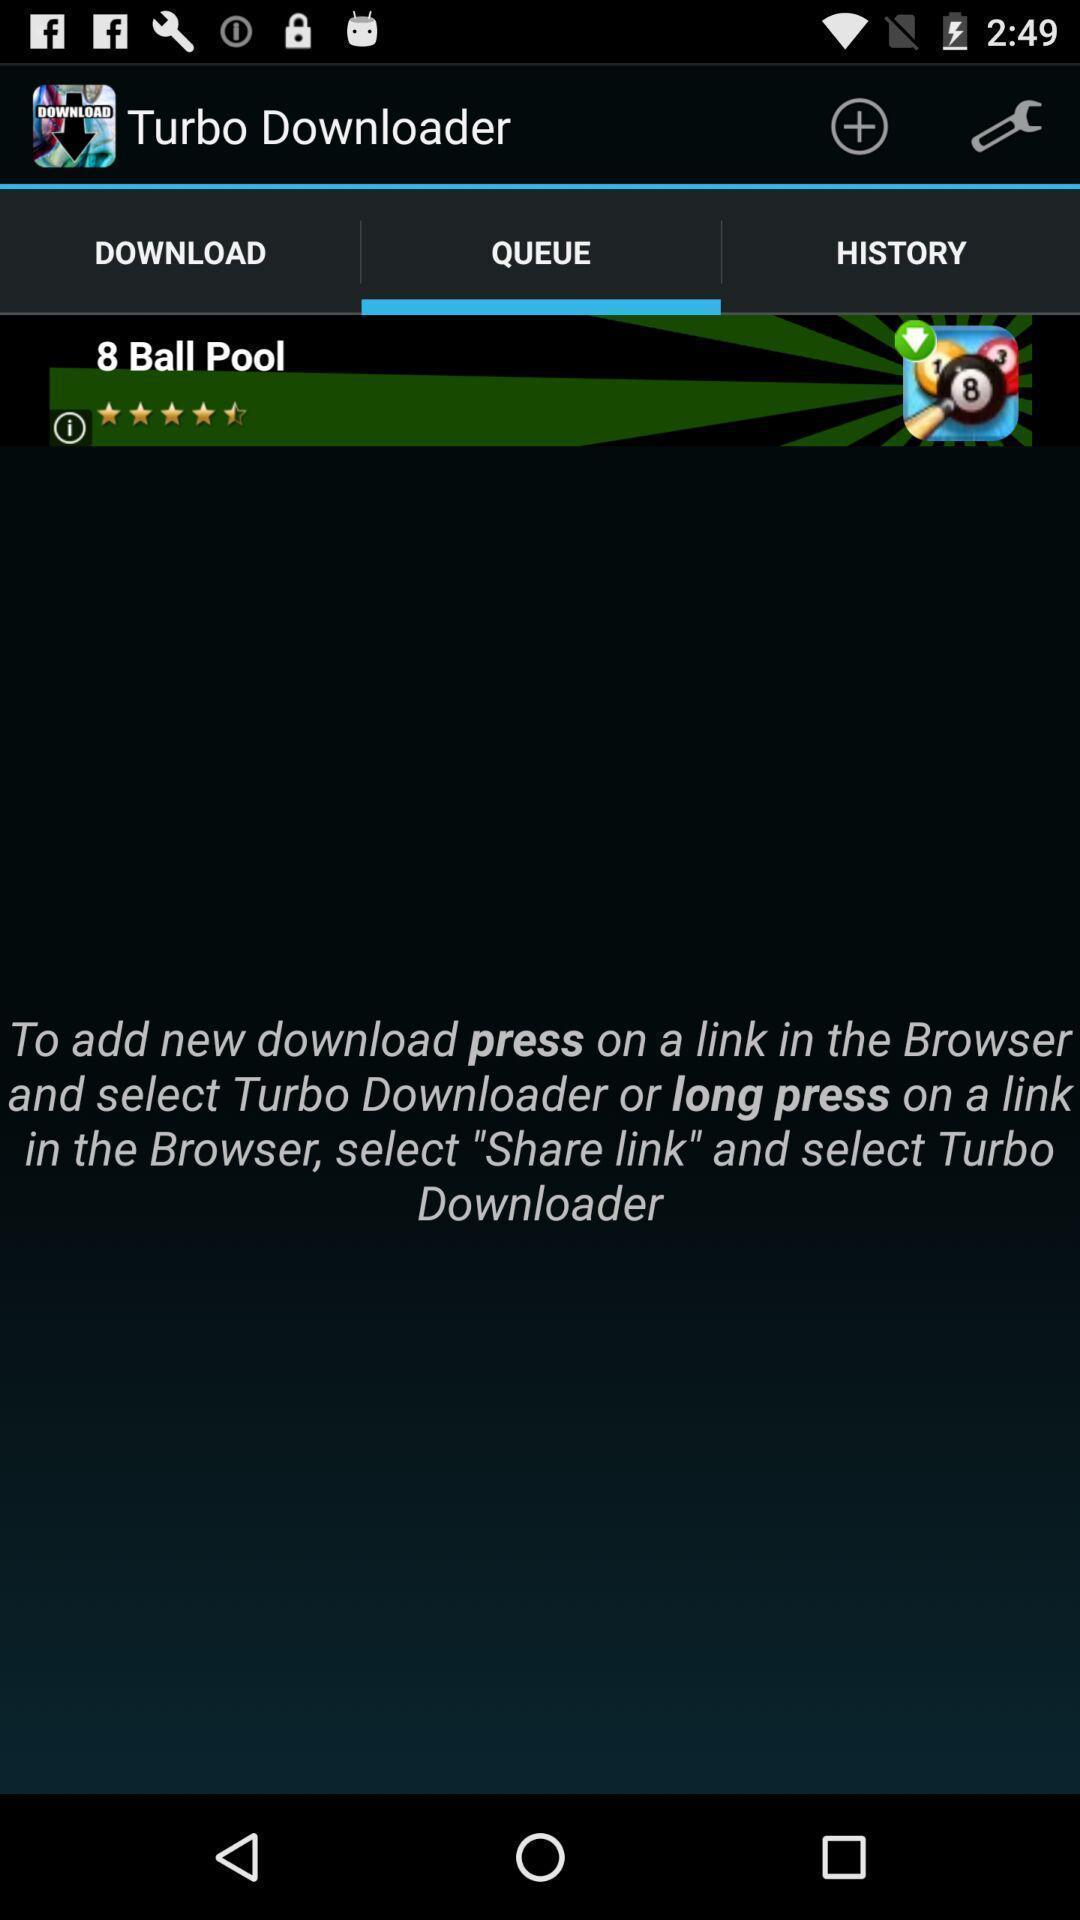Tell me what you see in this picture. Page displaying the queue of turbo downloader. 